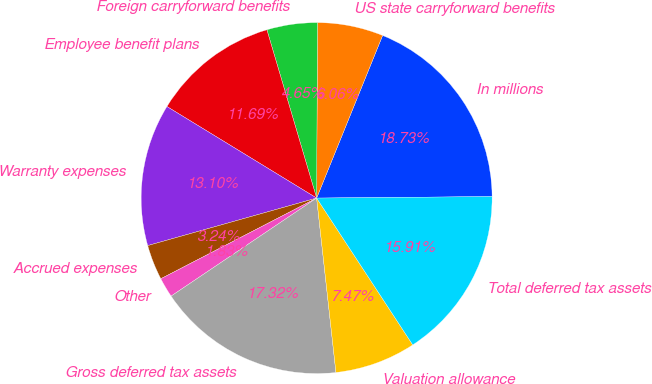Convert chart to OTSL. <chart><loc_0><loc_0><loc_500><loc_500><pie_chart><fcel>In millions<fcel>US state carryforward benefits<fcel>Foreign carryforward benefits<fcel>Employee benefit plans<fcel>Warranty expenses<fcel>Accrued expenses<fcel>Other<fcel>Gross deferred tax assets<fcel>Valuation allowance<fcel>Total deferred tax assets<nl><fcel>18.73%<fcel>6.06%<fcel>4.65%<fcel>11.69%<fcel>13.1%<fcel>3.24%<fcel>1.83%<fcel>17.32%<fcel>7.47%<fcel>15.91%<nl></chart> 